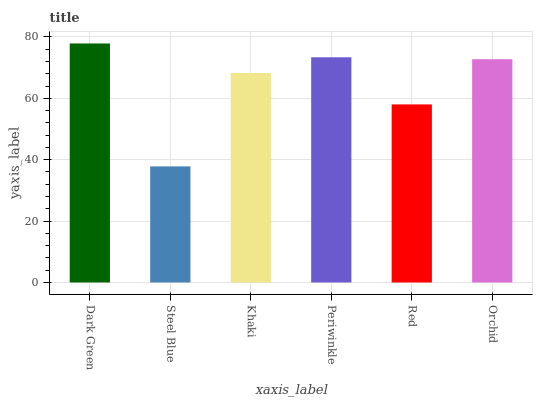Is Steel Blue the minimum?
Answer yes or no. Yes. Is Dark Green the maximum?
Answer yes or no. Yes. Is Khaki the minimum?
Answer yes or no. No. Is Khaki the maximum?
Answer yes or no. No. Is Khaki greater than Steel Blue?
Answer yes or no. Yes. Is Steel Blue less than Khaki?
Answer yes or no. Yes. Is Steel Blue greater than Khaki?
Answer yes or no. No. Is Khaki less than Steel Blue?
Answer yes or no. No. Is Orchid the high median?
Answer yes or no. Yes. Is Khaki the low median?
Answer yes or no. Yes. Is Red the high median?
Answer yes or no. No. Is Dark Green the low median?
Answer yes or no. No. 